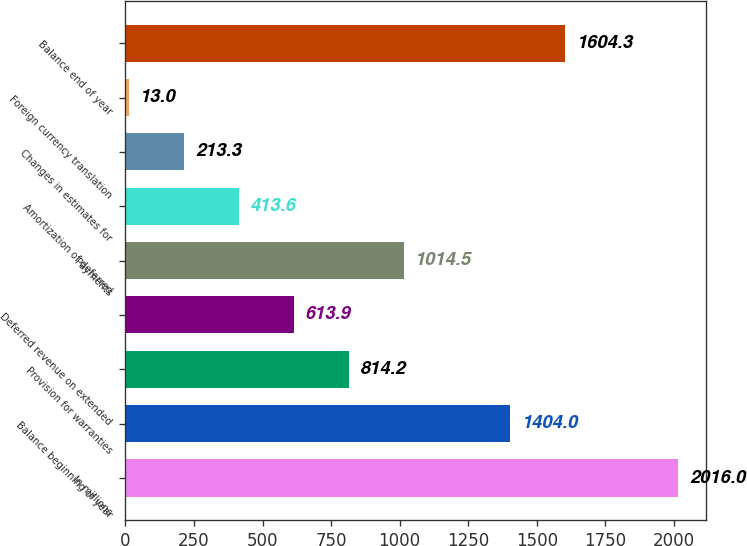Convert chart. <chart><loc_0><loc_0><loc_500><loc_500><bar_chart><fcel>In millions<fcel>Balance beginning of year<fcel>Provision for warranties<fcel>Deferred revenue on extended<fcel>Payments<fcel>Amortization of deferred<fcel>Changes in estimates for<fcel>Foreign currency translation<fcel>Balance end of year<nl><fcel>2016<fcel>1404<fcel>814.2<fcel>613.9<fcel>1014.5<fcel>413.6<fcel>213.3<fcel>13<fcel>1604.3<nl></chart> 